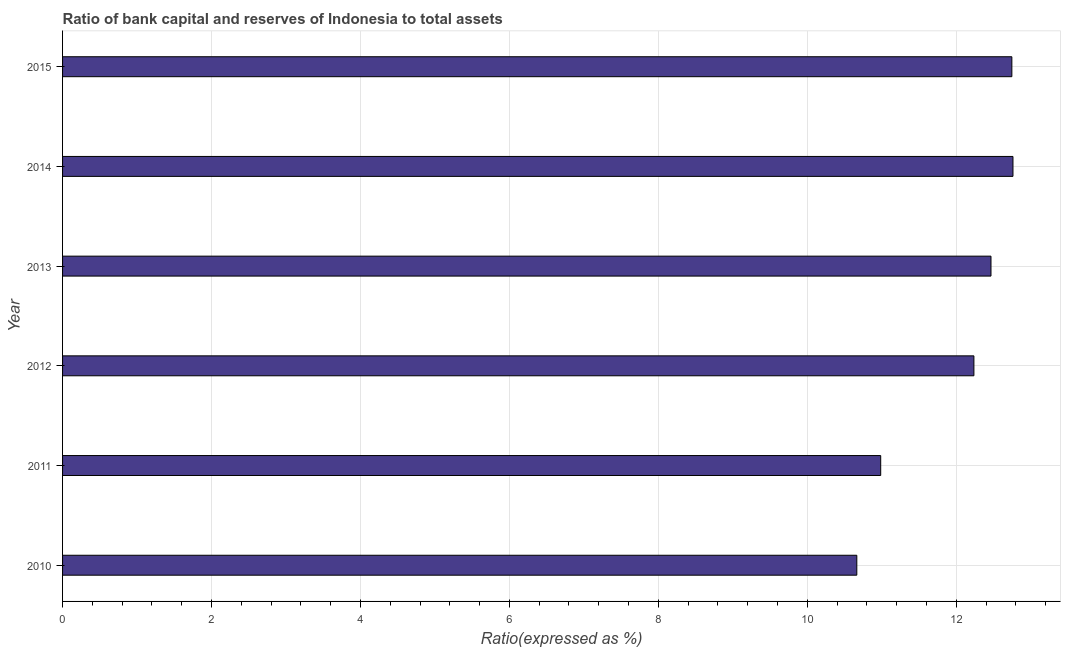Does the graph contain any zero values?
Your response must be concise. No. What is the title of the graph?
Keep it short and to the point. Ratio of bank capital and reserves of Indonesia to total assets. What is the label or title of the X-axis?
Make the answer very short. Ratio(expressed as %). What is the label or title of the Y-axis?
Your answer should be very brief. Year. What is the bank capital to assets ratio in 2015?
Make the answer very short. 12.75. Across all years, what is the maximum bank capital to assets ratio?
Offer a terse response. 12.76. Across all years, what is the minimum bank capital to assets ratio?
Ensure brevity in your answer.  10.66. In which year was the bank capital to assets ratio minimum?
Keep it short and to the point. 2010. What is the sum of the bank capital to assets ratio?
Provide a succinct answer. 71.86. What is the difference between the bank capital to assets ratio in 2011 and 2015?
Keep it short and to the point. -1.76. What is the average bank capital to assets ratio per year?
Your response must be concise. 11.98. What is the median bank capital to assets ratio?
Make the answer very short. 12.35. In how many years, is the bank capital to assets ratio greater than 2.4 %?
Ensure brevity in your answer.  6. Do a majority of the years between 2015 and 2011 (inclusive) have bank capital to assets ratio greater than 1.6 %?
Your answer should be very brief. Yes. Is the difference between the bank capital to assets ratio in 2012 and 2015 greater than the difference between any two years?
Provide a succinct answer. No. What is the difference between the highest and the second highest bank capital to assets ratio?
Ensure brevity in your answer.  0.01. Is the sum of the bank capital to assets ratio in 2011 and 2015 greater than the maximum bank capital to assets ratio across all years?
Your answer should be very brief. Yes. How many bars are there?
Give a very brief answer. 6. Are all the bars in the graph horizontal?
Ensure brevity in your answer.  Yes. What is the difference between two consecutive major ticks on the X-axis?
Give a very brief answer. 2. What is the Ratio(expressed as %) of 2010?
Provide a short and direct response. 10.66. What is the Ratio(expressed as %) in 2011?
Ensure brevity in your answer.  10.99. What is the Ratio(expressed as %) of 2012?
Provide a short and direct response. 12.24. What is the Ratio(expressed as %) in 2013?
Offer a terse response. 12.47. What is the Ratio(expressed as %) in 2014?
Provide a short and direct response. 12.76. What is the Ratio(expressed as %) in 2015?
Your answer should be very brief. 12.75. What is the difference between the Ratio(expressed as %) in 2010 and 2011?
Provide a short and direct response. -0.32. What is the difference between the Ratio(expressed as %) in 2010 and 2012?
Offer a very short reply. -1.57. What is the difference between the Ratio(expressed as %) in 2010 and 2013?
Ensure brevity in your answer.  -1.8. What is the difference between the Ratio(expressed as %) in 2010 and 2014?
Your answer should be very brief. -2.1. What is the difference between the Ratio(expressed as %) in 2010 and 2015?
Your answer should be very brief. -2.08. What is the difference between the Ratio(expressed as %) in 2011 and 2012?
Provide a short and direct response. -1.25. What is the difference between the Ratio(expressed as %) in 2011 and 2013?
Your response must be concise. -1.48. What is the difference between the Ratio(expressed as %) in 2011 and 2014?
Ensure brevity in your answer.  -1.78. What is the difference between the Ratio(expressed as %) in 2011 and 2015?
Ensure brevity in your answer.  -1.76. What is the difference between the Ratio(expressed as %) in 2012 and 2013?
Your answer should be very brief. -0.23. What is the difference between the Ratio(expressed as %) in 2012 and 2014?
Make the answer very short. -0.52. What is the difference between the Ratio(expressed as %) in 2012 and 2015?
Provide a short and direct response. -0.51. What is the difference between the Ratio(expressed as %) in 2013 and 2014?
Your response must be concise. -0.3. What is the difference between the Ratio(expressed as %) in 2013 and 2015?
Your answer should be very brief. -0.28. What is the difference between the Ratio(expressed as %) in 2014 and 2015?
Your response must be concise. 0.01. What is the ratio of the Ratio(expressed as %) in 2010 to that in 2011?
Offer a very short reply. 0.97. What is the ratio of the Ratio(expressed as %) in 2010 to that in 2012?
Provide a short and direct response. 0.87. What is the ratio of the Ratio(expressed as %) in 2010 to that in 2013?
Your answer should be very brief. 0.85. What is the ratio of the Ratio(expressed as %) in 2010 to that in 2014?
Offer a terse response. 0.84. What is the ratio of the Ratio(expressed as %) in 2010 to that in 2015?
Offer a very short reply. 0.84. What is the ratio of the Ratio(expressed as %) in 2011 to that in 2012?
Ensure brevity in your answer.  0.9. What is the ratio of the Ratio(expressed as %) in 2011 to that in 2013?
Provide a succinct answer. 0.88. What is the ratio of the Ratio(expressed as %) in 2011 to that in 2014?
Your response must be concise. 0.86. What is the ratio of the Ratio(expressed as %) in 2011 to that in 2015?
Offer a terse response. 0.86. What is the ratio of the Ratio(expressed as %) in 2012 to that in 2013?
Your answer should be very brief. 0.98. What is the ratio of the Ratio(expressed as %) in 2013 to that in 2014?
Give a very brief answer. 0.98. What is the ratio of the Ratio(expressed as %) in 2013 to that in 2015?
Ensure brevity in your answer.  0.98. What is the ratio of the Ratio(expressed as %) in 2014 to that in 2015?
Offer a very short reply. 1. 